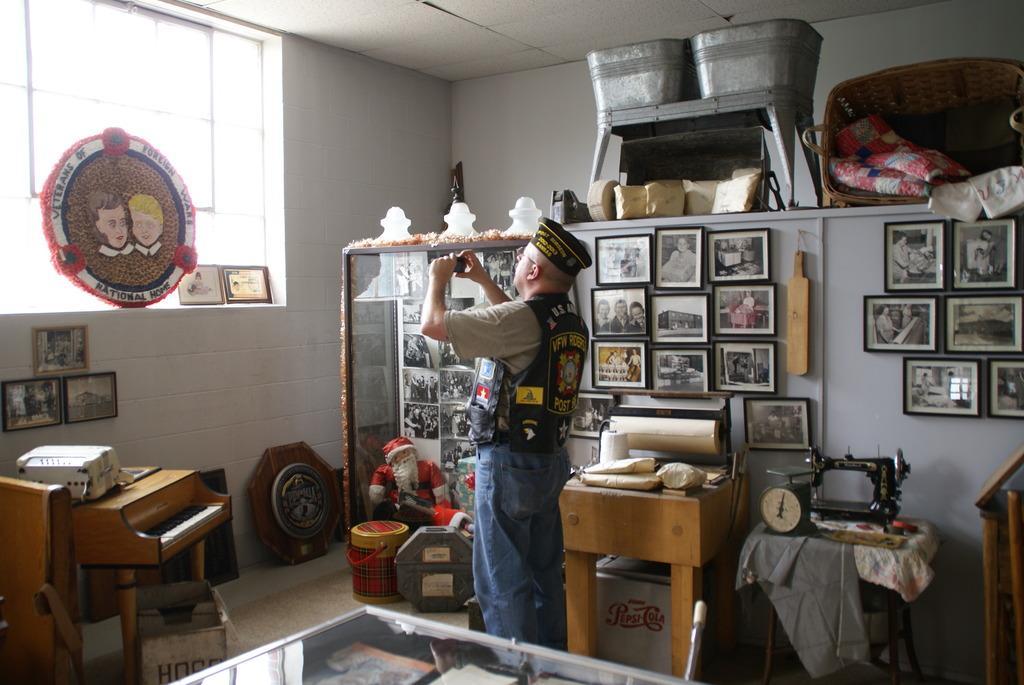How would you summarize this image in a sentence or two? In this image i can see man standing holding a camera at the back ground i can see few frames, bat attached to a wall , i can also see few pillows at right there is a board a window and a wall. 